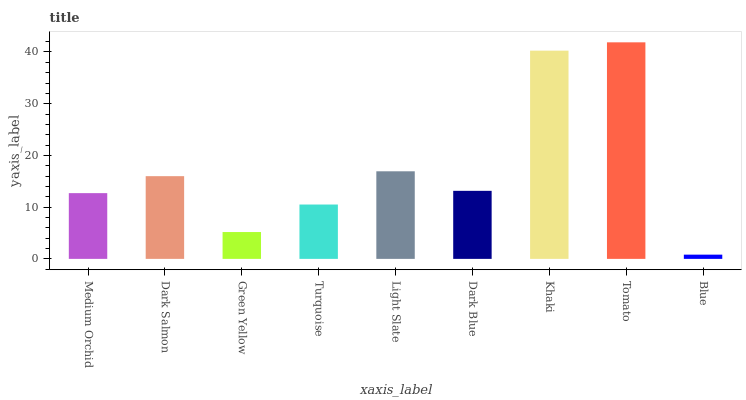Is Blue the minimum?
Answer yes or no. Yes. Is Tomato the maximum?
Answer yes or no. Yes. Is Dark Salmon the minimum?
Answer yes or no. No. Is Dark Salmon the maximum?
Answer yes or no. No. Is Dark Salmon greater than Medium Orchid?
Answer yes or no. Yes. Is Medium Orchid less than Dark Salmon?
Answer yes or no. Yes. Is Medium Orchid greater than Dark Salmon?
Answer yes or no. No. Is Dark Salmon less than Medium Orchid?
Answer yes or no. No. Is Dark Blue the high median?
Answer yes or no. Yes. Is Dark Blue the low median?
Answer yes or no. Yes. Is Light Slate the high median?
Answer yes or no. No. Is Khaki the low median?
Answer yes or no. No. 